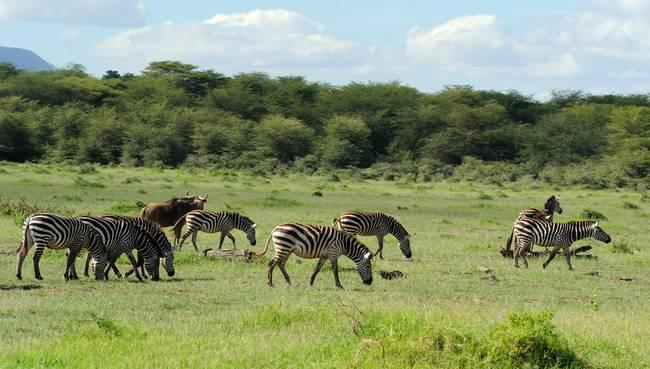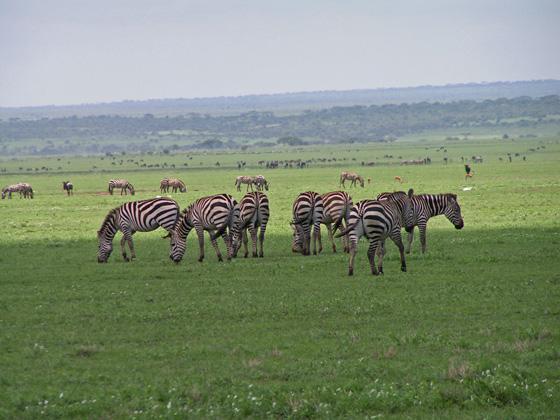The first image is the image on the left, the second image is the image on the right. Analyze the images presented: Is the assertion "IN at least one image there are at least 4 zebras facing away from the camera looking at a different breed of animal." valid? Answer yes or no. No. The first image is the image on the left, the second image is the image on the right. Analyze the images presented: Is the assertion "An image shows several zebras with their backs to the camera facing a group of at least five hooved animals belonging to one other species." valid? Answer yes or no. No. 